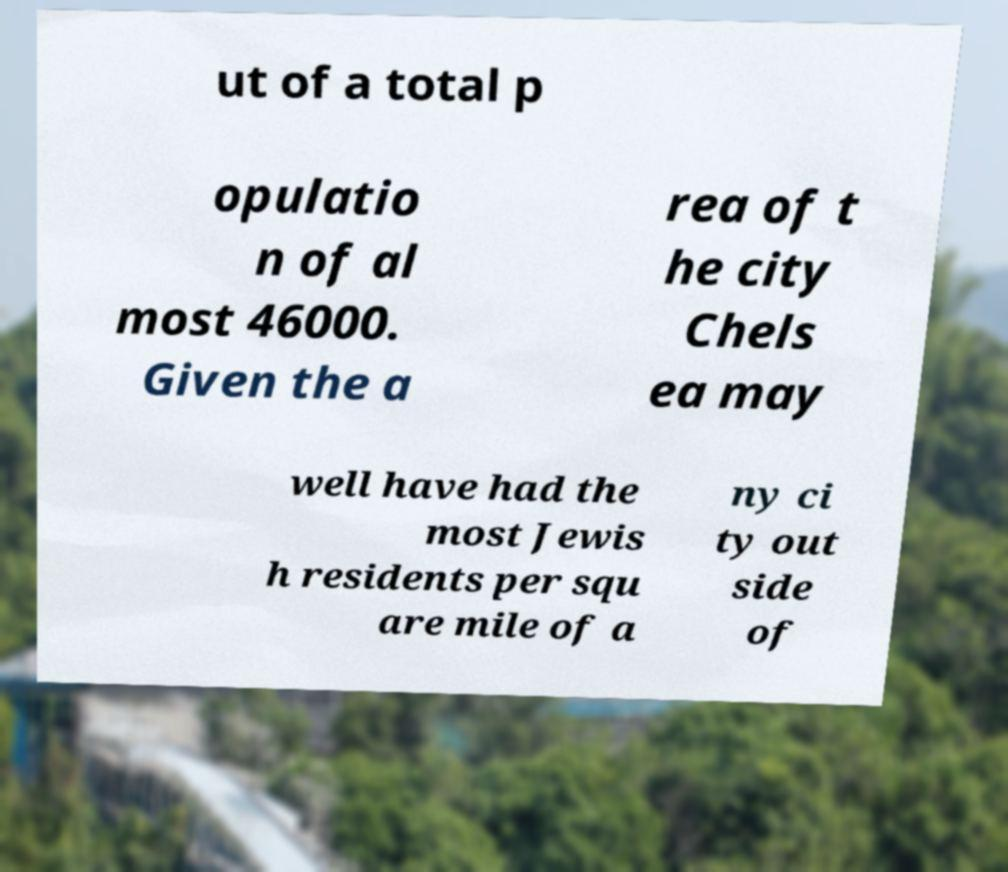Could you extract and type out the text from this image? ut of a total p opulatio n of al most 46000. Given the a rea of t he city Chels ea may well have had the most Jewis h residents per squ are mile of a ny ci ty out side of 